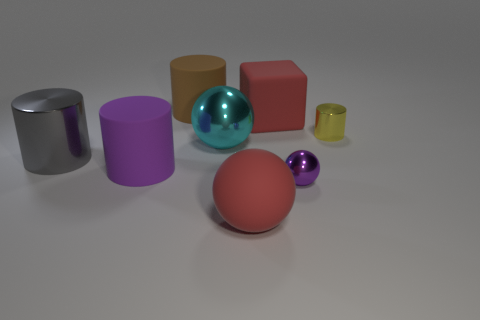Does the large brown thing have the same shape as the cyan metal thing?
Keep it short and to the point. No. There is a large object that is behind the small yellow cylinder and in front of the big brown thing; what color is it?
Provide a short and direct response. Red. There is a rubber sphere that is the same color as the big matte cube; what is its size?
Give a very brief answer. Large. Is there anything else that is the same color as the large matte cube?
Your response must be concise. Yes. There is a small metallic object that is on the left side of the yellow metal cylinder; is it the same color as the block?
Ensure brevity in your answer.  No. Is the material of the cyan object the same as the gray thing?
Make the answer very short. Yes. Is the number of big red rubber balls that are to the left of the large brown rubber thing the same as the number of big red objects that are on the left side of the yellow thing?
Keep it short and to the point. No. There is a gray thing that is the same shape as the tiny yellow metal object; what is it made of?
Offer a very short reply. Metal. What is the shape of the large thing that is the same color as the large matte ball?
Keep it short and to the point. Cube. Are there any other red cubes that have the same material as the cube?
Make the answer very short. No. 